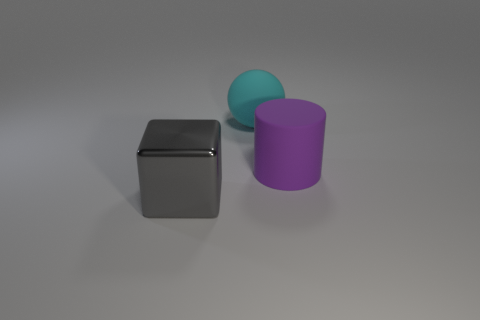Add 1 purple balls. How many objects exist? 4 Subtract all cubes. How many objects are left? 2 Add 2 small brown cylinders. How many small brown cylinders exist? 2 Subtract 0 cyan cylinders. How many objects are left? 3 Subtract all purple rubber objects. Subtract all yellow metal cylinders. How many objects are left? 2 Add 3 gray metal cubes. How many gray metal cubes are left? 4 